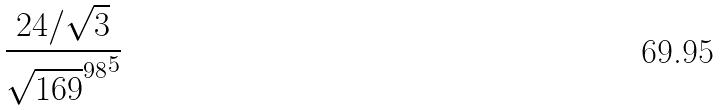<formula> <loc_0><loc_0><loc_500><loc_500>\frac { 2 4 / \sqrt { 3 } } { { \sqrt { 1 6 9 } ^ { 9 8 } } ^ { 5 } }</formula> 